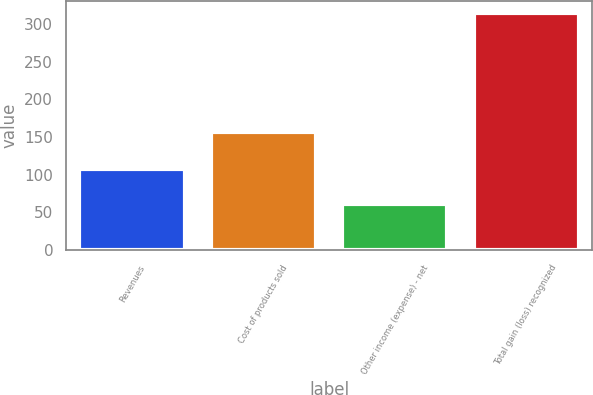<chart> <loc_0><loc_0><loc_500><loc_500><bar_chart><fcel>Revenues<fcel>Cost of products sold<fcel>Other income (expense) - net<fcel>Total gain (loss) recognized<nl><fcel>108<fcel>157<fcel>61<fcel>314<nl></chart> 